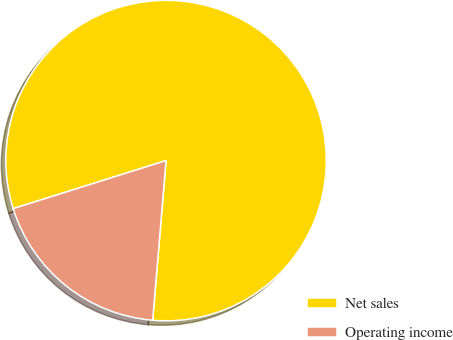<chart> <loc_0><loc_0><loc_500><loc_500><pie_chart><fcel>Net sales<fcel>Operating income<nl><fcel>81.18%<fcel>18.82%<nl></chart> 